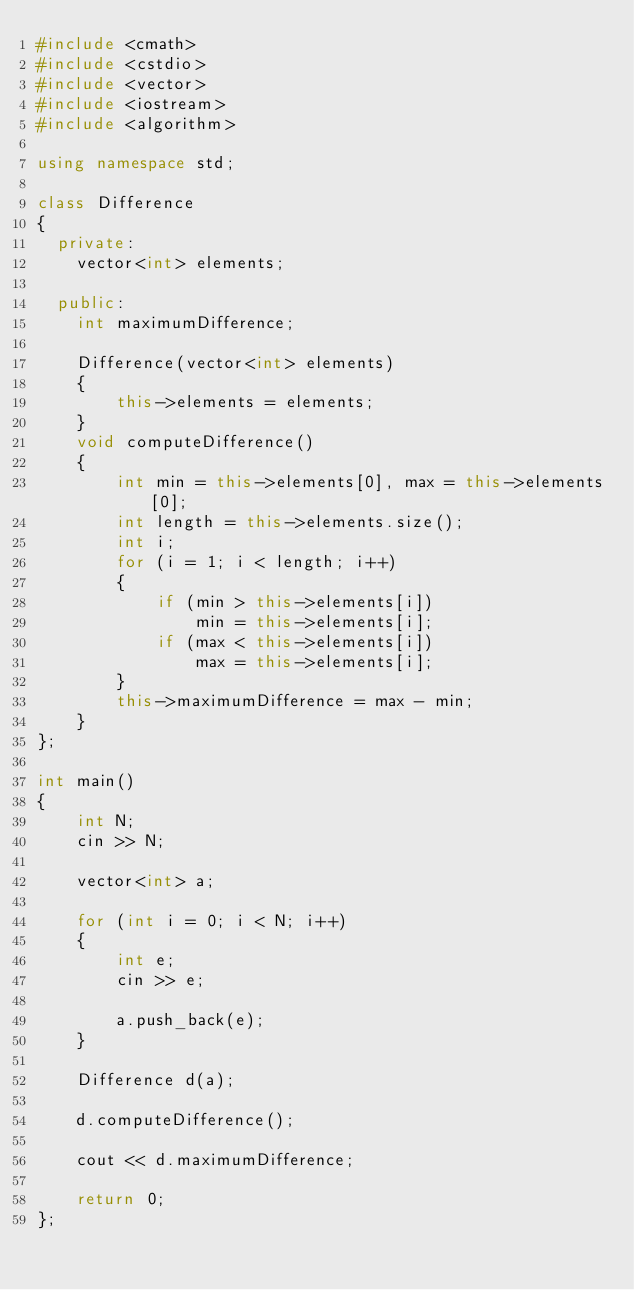<code> <loc_0><loc_0><loc_500><loc_500><_C++_>#include <cmath>
#include <cstdio>
#include <vector>
#include <iostream>
#include <algorithm>

using namespace std;

class Difference
{
  private:
    vector<int> elements;

  public:
    int maximumDifference;

    Difference(vector<int> elements)
    {
        this->elements = elements;
    }
    void computeDifference()
    {
        int min = this->elements[0], max = this->elements[0];
        int length = this->elements.size();
        int i;
        for (i = 1; i < length; i++)
        {
            if (min > this->elements[i])
                min = this->elements[i];
            if (max < this->elements[i])
                max = this->elements[i];
        }
        this->maximumDifference = max - min;
    }
};

int main()
{
    int N;
    cin >> N;

    vector<int> a;

    for (int i = 0; i < N; i++)
    {
        int e;
        cin >> e;

        a.push_back(e);
    }

    Difference d(a);

    d.computeDifference();

    cout << d.maximumDifference;

    return 0;
};</code> 